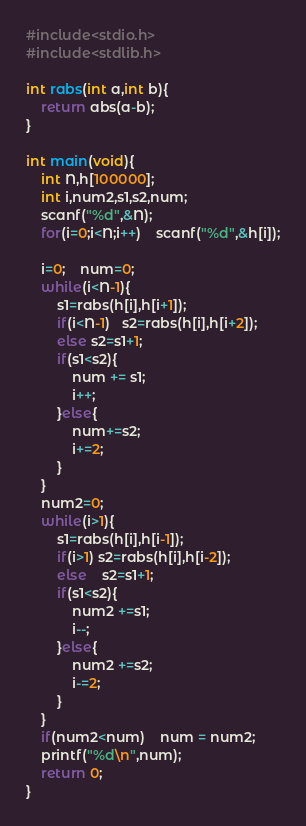Convert code to text. <code><loc_0><loc_0><loc_500><loc_500><_C_>#include<stdio.h>
#include<stdlib.h>

int rabs(int a,int b){
    return abs(a-b);
}

int main(void){
    int N,h[100000];
    int i,num2,s1,s2,num;
    scanf("%d",&N);
    for(i=0;i<N;i++)    scanf("%d",&h[i]);

    i=0;    num=0;
    while(i<N-1){
        s1=rabs(h[i],h[i+1]);
        if(i<N-1)   s2=rabs(h[i],h[i+2]);
        else s2=s1+1;
        if(s1<s2){
            num += s1;
            i++;
        }else{
            num+=s2;
            i+=2;
        }
    }
    num2=0;
    while(i>1){
        s1=rabs(h[i],h[i-1]);
        if(i>1) s2=rabs(h[i],h[i-2]);
        else    s2=s1+1;
        if(s1<s2){
            num2 +=s1;
            i--;
        }else{
            num2 +=s2;
            i-=2;
        }
    }
    if(num2<num)    num = num2;
    printf("%d\n",num);
    return 0;
}
</code> 